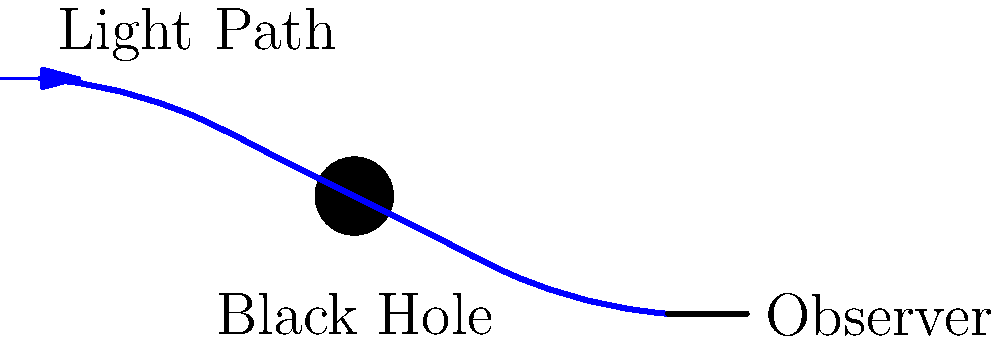In the diagram above, light from a distant star is bent around a black hole before reaching an observer. This phenomenon is known as gravitational lensing. If the black hole's mass were to increase, how would this affect the path of light observed? To understand how an increase in the black hole's mass would affect the light path, let's break it down step-by-step:

1. Gravitational lensing is caused by the curvature of spacetime around massive objects, as described by Einstein's theory of general relativity.

2. The strength of gravitational lensing depends on the mass of the lensing object (in this case, the black hole). The relationship is given by the equation:

   $$\alpha = \frac{4GM}{c^2b}$$

   Where $\alpha$ is the deflection angle, $G$ is the gravitational constant, $M$ is the mass of the lensing object, $c$ is the speed of light, and $b$ is the impact parameter (closest approach of the light to the center of the lensing object).

3. If the mass ($M$) of the black hole increases, the numerator in the equation above becomes larger.

4. With a larger numerator and all other factors remaining constant, the deflection angle $\alpha$ increases.

5. A larger deflection angle means that the light path will bend more sharply around the black hole.

6. In the diagram, this would be represented by a more pronounced curve in the light path, bringing it closer to the black hole before bending away more sharply.

7. From the observer's perspective, this increased bending would make the source of the light appear to be in a different position than it actually is, and the image might appear more distorted or magnified.

Therefore, an increase in the black hole's mass would result in a more pronounced bending of the light path around the black hole.
Answer: The light path would bend more sharply around the black hole. 